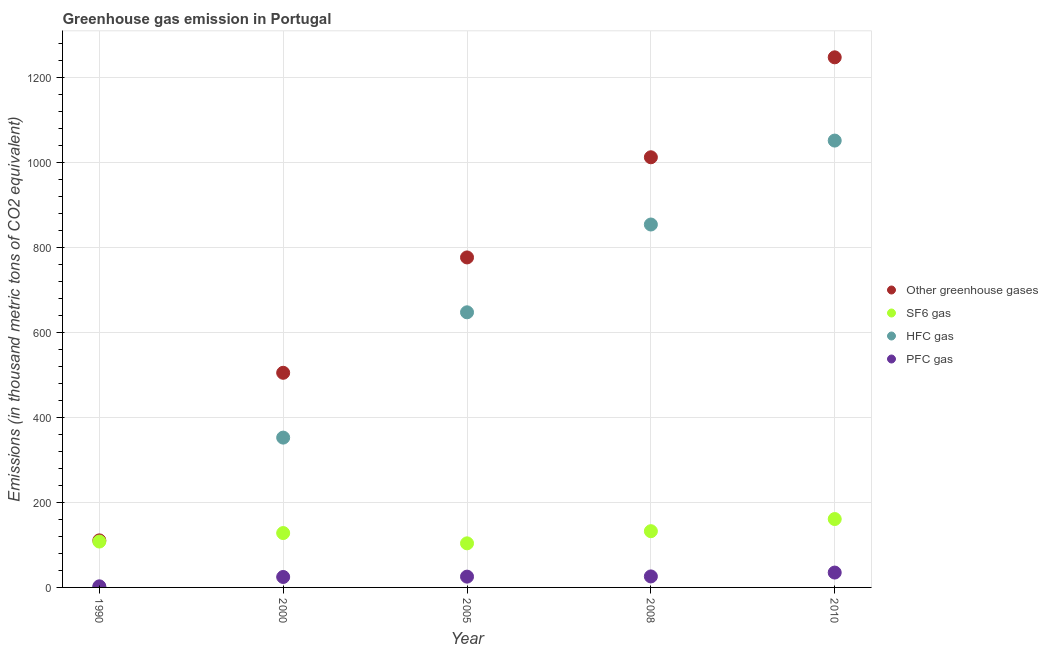How many different coloured dotlines are there?
Offer a very short reply. 4. Is the number of dotlines equal to the number of legend labels?
Give a very brief answer. Yes. What is the emission of hfc gas in 2008?
Offer a terse response. 854.4. Across all years, what is the maximum emission of greenhouse gases?
Your answer should be very brief. 1248. Across all years, what is the minimum emission of hfc gas?
Ensure brevity in your answer.  0.2. In which year was the emission of greenhouse gases maximum?
Your answer should be compact. 2010. What is the total emission of sf6 gas in the graph?
Ensure brevity in your answer.  633.2. What is the difference between the emission of greenhouse gases in 2005 and that in 2008?
Your response must be concise. -235.8. What is the difference between the emission of sf6 gas in 1990 and the emission of greenhouse gases in 2005?
Offer a very short reply. -668.9. What is the average emission of greenhouse gases per year?
Make the answer very short. 730.74. In the year 2000, what is the difference between the emission of greenhouse gases and emission of pfc gas?
Offer a very short reply. 480.7. What is the ratio of the emission of greenhouse gases in 2000 to that in 2010?
Ensure brevity in your answer.  0.4. Is the emission of hfc gas in 1990 less than that in 2008?
Offer a terse response. Yes. Is the difference between the emission of hfc gas in 2005 and 2008 greater than the difference between the emission of greenhouse gases in 2005 and 2008?
Offer a very short reply. Yes. What is the difference between the highest and the second highest emission of pfc gas?
Offer a very short reply. 9.1. What is the difference between the highest and the lowest emission of hfc gas?
Provide a succinct answer. 1051.8. In how many years, is the emission of pfc gas greater than the average emission of pfc gas taken over all years?
Ensure brevity in your answer.  4. Is the sum of the emission of sf6 gas in 1990 and 2000 greater than the maximum emission of greenhouse gases across all years?
Make the answer very short. No. Does the emission of sf6 gas monotonically increase over the years?
Offer a very short reply. No. Is the emission of pfc gas strictly less than the emission of hfc gas over the years?
Keep it short and to the point. No. How many dotlines are there?
Offer a very short reply. 4. How many years are there in the graph?
Give a very brief answer. 5. Are the values on the major ticks of Y-axis written in scientific E-notation?
Offer a very short reply. No. Does the graph contain any zero values?
Your answer should be very brief. No. Where does the legend appear in the graph?
Your answer should be compact. Center right. How many legend labels are there?
Your response must be concise. 4. What is the title of the graph?
Your answer should be compact. Greenhouse gas emission in Portugal. Does "Energy" appear as one of the legend labels in the graph?
Make the answer very short. No. What is the label or title of the X-axis?
Offer a very short reply. Year. What is the label or title of the Y-axis?
Offer a very short reply. Emissions (in thousand metric tons of CO2 equivalent). What is the Emissions (in thousand metric tons of CO2 equivalent) in Other greenhouse gases in 1990?
Your answer should be very brief. 110.8. What is the Emissions (in thousand metric tons of CO2 equivalent) in SF6 gas in 1990?
Keep it short and to the point. 108. What is the Emissions (in thousand metric tons of CO2 equivalent) of HFC gas in 1990?
Offer a terse response. 0.2. What is the Emissions (in thousand metric tons of CO2 equivalent) of Other greenhouse gases in 2000?
Provide a succinct answer. 505.3. What is the Emissions (in thousand metric tons of CO2 equivalent) in SF6 gas in 2000?
Make the answer very short. 128. What is the Emissions (in thousand metric tons of CO2 equivalent) in HFC gas in 2000?
Your response must be concise. 352.7. What is the Emissions (in thousand metric tons of CO2 equivalent) in PFC gas in 2000?
Ensure brevity in your answer.  24.6. What is the Emissions (in thousand metric tons of CO2 equivalent) in Other greenhouse gases in 2005?
Make the answer very short. 776.9. What is the Emissions (in thousand metric tons of CO2 equivalent) in SF6 gas in 2005?
Offer a very short reply. 103.8. What is the Emissions (in thousand metric tons of CO2 equivalent) in HFC gas in 2005?
Your response must be concise. 647.7. What is the Emissions (in thousand metric tons of CO2 equivalent) of PFC gas in 2005?
Your response must be concise. 25.4. What is the Emissions (in thousand metric tons of CO2 equivalent) of Other greenhouse gases in 2008?
Provide a short and direct response. 1012.7. What is the Emissions (in thousand metric tons of CO2 equivalent) in SF6 gas in 2008?
Offer a very short reply. 132.4. What is the Emissions (in thousand metric tons of CO2 equivalent) of HFC gas in 2008?
Make the answer very short. 854.4. What is the Emissions (in thousand metric tons of CO2 equivalent) in PFC gas in 2008?
Your answer should be very brief. 25.9. What is the Emissions (in thousand metric tons of CO2 equivalent) of Other greenhouse gases in 2010?
Your response must be concise. 1248. What is the Emissions (in thousand metric tons of CO2 equivalent) in SF6 gas in 2010?
Your answer should be compact. 161. What is the Emissions (in thousand metric tons of CO2 equivalent) in HFC gas in 2010?
Make the answer very short. 1052. What is the Emissions (in thousand metric tons of CO2 equivalent) of PFC gas in 2010?
Offer a very short reply. 35. Across all years, what is the maximum Emissions (in thousand metric tons of CO2 equivalent) in Other greenhouse gases?
Offer a terse response. 1248. Across all years, what is the maximum Emissions (in thousand metric tons of CO2 equivalent) in SF6 gas?
Make the answer very short. 161. Across all years, what is the maximum Emissions (in thousand metric tons of CO2 equivalent) in HFC gas?
Your answer should be compact. 1052. Across all years, what is the minimum Emissions (in thousand metric tons of CO2 equivalent) of Other greenhouse gases?
Make the answer very short. 110.8. Across all years, what is the minimum Emissions (in thousand metric tons of CO2 equivalent) in SF6 gas?
Your answer should be very brief. 103.8. Across all years, what is the minimum Emissions (in thousand metric tons of CO2 equivalent) of PFC gas?
Your response must be concise. 2.6. What is the total Emissions (in thousand metric tons of CO2 equivalent) in Other greenhouse gases in the graph?
Keep it short and to the point. 3653.7. What is the total Emissions (in thousand metric tons of CO2 equivalent) of SF6 gas in the graph?
Your response must be concise. 633.2. What is the total Emissions (in thousand metric tons of CO2 equivalent) of HFC gas in the graph?
Your response must be concise. 2907. What is the total Emissions (in thousand metric tons of CO2 equivalent) of PFC gas in the graph?
Keep it short and to the point. 113.5. What is the difference between the Emissions (in thousand metric tons of CO2 equivalent) in Other greenhouse gases in 1990 and that in 2000?
Your answer should be compact. -394.5. What is the difference between the Emissions (in thousand metric tons of CO2 equivalent) in HFC gas in 1990 and that in 2000?
Give a very brief answer. -352.5. What is the difference between the Emissions (in thousand metric tons of CO2 equivalent) in Other greenhouse gases in 1990 and that in 2005?
Give a very brief answer. -666.1. What is the difference between the Emissions (in thousand metric tons of CO2 equivalent) in HFC gas in 1990 and that in 2005?
Your response must be concise. -647.5. What is the difference between the Emissions (in thousand metric tons of CO2 equivalent) in PFC gas in 1990 and that in 2005?
Make the answer very short. -22.8. What is the difference between the Emissions (in thousand metric tons of CO2 equivalent) of Other greenhouse gases in 1990 and that in 2008?
Provide a succinct answer. -901.9. What is the difference between the Emissions (in thousand metric tons of CO2 equivalent) in SF6 gas in 1990 and that in 2008?
Offer a terse response. -24.4. What is the difference between the Emissions (in thousand metric tons of CO2 equivalent) of HFC gas in 1990 and that in 2008?
Ensure brevity in your answer.  -854.2. What is the difference between the Emissions (in thousand metric tons of CO2 equivalent) of PFC gas in 1990 and that in 2008?
Make the answer very short. -23.3. What is the difference between the Emissions (in thousand metric tons of CO2 equivalent) in Other greenhouse gases in 1990 and that in 2010?
Provide a succinct answer. -1137.2. What is the difference between the Emissions (in thousand metric tons of CO2 equivalent) in SF6 gas in 1990 and that in 2010?
Give a very brief answer. -53. What is the difference between the Emissions (in thousand metric tons of CO2 equivalent) of HFC gas in 1990 and that in 2010?
Give a very brief answer. -1051.8. What is the difference between the Emissions (in thousand metric tons of CO2 equivalent) in PFC gas in 1990 and that in 2010?
Offer a very short reply. -32.4. What is the difference between the Emissions (in thousand metric tons of CO2 equivalent) of Other greenhouse gases in 2000 and that in 2005?
Offer a terse response. -271.6. What is the difference between the Emissions (in thousand metric tons of CO2 equivalent) in SF6 gas in 2000 and that in 2005?
Provide a succinct answer. 24.2. What is the difference between the Emissions (in thousand metric tons of CO2 equivalent) of HFC gas in 2000 and that in 2005?
Offer a terse response. -295. What is the difference between the Emissions (in thousand metric tons of CO2 equivalent) in Other greenhouse gases in 2000 and that in 2008?
Make the answer very short. -507.4. What is the difference between the Emissions (in thousand metric tons of CO2 equivalent) in HFC gas in 2000 and that in 2008?
Make the answer very short. -501.7. What is the difference between the Emissions (in thousand metric tons of CO2 equivalent) of PFC gas in 2000 and that in 2008?
Give a very brief answer. -1.3. What is the difference between the Emissions (in thousand metric tons of CO2 equivalent) of Other greenhouse gases in 2000 and that in 2010?
Provide a succinct answer. -742.7. What is the difference between the Emissions (in thousand metric tons of CO2 equivalent) of SF6 gas in 2000 and that in 2010?
Your answer should be compact. -33. What is the difference between the Emissions (in thousand metric tons of CO2 equivalent) in HFC gas in 2000 and that in 2010?
Keep it short and to the point. -699.3. What is the difference between the Emissions (in thousand metric tons of CO2 equivalent) of PFC gas in 2000 and that in 2010?
Make the answer very short. -10.4. What is the difference between the Emissions (in thousand metric tons of CO2 equivalent) in Other greenhouse gases in 2005 and that in 2008?
Make the answer very short. -235.8. What is the difference between the Emissions (in thousand metric tons of CO2 equivalent) in SF6 gas in 2005 and that in 2008?
Your response must be concise. -28.6. What is the difference between the Emissions (in thousand metric tons of CO2 equivalent) in HFC gas in 2005 and that in 2008?
Offer a very short reply. -206.7. What is the difference between the Emissions (in thousand metric tons of CO2 equivalent) in Other greenhouse gases in 2005 and that in 2010?
Offer a very short reply. -471.1. What is the difference between the Emissions (in thousand metric tons of CO2 equivalent) of SF6 gas in 2005 and that in 2010?
Provide a succinct answer. -57.2. What is the difference between the Emissions (in thousand metric tons of CO2 equivalent) in HFC gas in 2005 and that in 2010?
Offer a terse response. -404.3. What is the difference between the Emissions (in thousand metric tons of CO2 equivalent) of PFC gas in 2005 and that in 2010?
Make the answer very short. -9.6. What is the difference between the Emissions (in thousand metric tons of CO2 equivalent) in Other greenhouse gases in 2008 and that in 2010?
Offer a very short reply. -235.3. What is the difference between the Emissions (in thousand metric tons of CO2 equivalent) in SF6 gas in 2008 and that in 2010?
Give a very brief answer. -28.6. What is the difference between the Emissions (in thousand metric tons of CO2 equivalent) in HFC gas in 2008 and that in 2010?
Ensure brevity in your answer.  -197.6. What is the difference between the Emissions (in thousand metric tons of CO2 equivalent) in PFC gas in 2008 and that in 2010?
Provide a succinct answer. -9.1. What is the difference between the Emissions (in thousand metric tons of CO2 equivalent) of Other greenhouse gases in 1990 and the Emissions (in thousand metric tons of CO2 equivalent) of SF6 gas in 2000?
Make the answer very short. -17.2. What is the difference between the Emissions (in thousand metric tons of CO2 equivalent) of Other greenhouse gases in 1990 and the Emissions (in thousand metric tons of CO2 equivalent) of HFC gas in 2000?
Make the answer very short. -241.9. What is the difference between the Emissions (in thousand metric tons of CO2 equivalent) in Other greenhouse gases in 1990 and the Emissions (in thousand metric tons of CO2 equivalent) in PFC gas in 2000?
Make the answer very short. 86.2. What is the difference between the Emissions (in thousand metric tons of CO2 equivalent) of SF6 gas in 1990 and the Emissions (in thousand metric tons of CO2 equivalent) of HFC gas in 2000?
Make the answer very short. -244.7. What is the difference between the Emissions (in thousand metric tons of CO2 equivalent) of SF6 gas in 1990 and the Emissions (in thousand metric tons of CO2 equivalent) of PFC gas in 2000?
Ensure brevity in your answer.  83.4. What is the difference between the Emissions (in thousand metric tons of CO2 equivalent) of HFC gas in 1990 and the Emissions (in thousand metric tons of CO2 equivalent) of PFC gas in 2000?
Offer a terse response. -24.4. What is the difference between the Emissions (in thousand metric tons of CO2 equivalent) of Other greenhouse gases in 1990 and the Emissions (in thousand metric tons of CO2 equivalent) of SF6 gas in 2005?
Your answer should be compact. 7. What is the difference between the Emissions (in thousand metric tons of CO2 equivalent) of Other greenhouse gases in 1990 and the Emissions (in thousand metric tons of CO2 equivalent) of HFC gas in 2005?
Your answer should be very brief. -536.9. What is the difference between the Emissions (in thousand metric tons of CO2 equivalent) of Other greenhouse gases in 1990 and the Emissions (in thousand metric tons of CO2 equivalent) of PFC gas in 2005?
Your response must be concise. 85.4. What is the difference between the Emissions (in thousand metric tons of CO2 equivalent) in SF6 gas in 1990 and the Emissions (in thousand metric tons of CO2 equivalent) in HFC gas in 2005?
Your response must be concise. -539.7. What is the difference between the Emissions (in thousand metric tons of CO2 equivalent) in SF6 gas in 1990 and the Emissions (in thousand metric tons of CO2 equivalent) in PFC gas in 2005?
Give a very brief answer. 82.6. What is the difference between the Emissions (in thousand metric tons of CO2 equivalent) of HFC gas in 1990 and the Emissions (in thousand metric tons of CO2 equivalent) of PFC gas in 2005?
Offer a terse response. -25.2. What is the difference between the Emissions (in thousand metric tons of CO2 equivalent) in Other greenhouse gases in 1990 and the Emissions (in thousand metric tons of CO2 equivalent) in SF6 gas in 2008?
Keep it short and to the point. -21.6. What is the difference between the Emissions (in thousand metric tons of CO2 equivalent) of Other greenhouse gases in 1990 and the Emissions (in thousand metric tons of CO2 equivalent) of HFC gas in 2008?
Your answer should be compact. -743.6. What is the difference between the Emissions (in thousand metric tons of CO2 equivalent) in Other greenhouse gases in 1990 and the Emissions (in thousand metric tons of CO2 equivalent) in PFC gas in 2008?
Make the answer very short. 84.9. What is the difference between the Emissions (in thousand metric tons of CO2 equivalent) of SF6 gas in 1990 and the Emissions (in thousand metric tons of CO2 equivalent) of HFC gas in 2008?
Your answer should be very brief. -746.4. What is the difference between the Emissions (in thousand metric tons of CO2 equivalent) in SF6 gas in 1990 and the Emissions (in thousand metric tons of CO2 equivalent) in PFC gas in 2008?
Your answer should be compact. 82.1. What is the difference between the Emissions (in thousand metric tons of CO2 equivalent) in HFC gas in 1990 and the Emissions (in thousand metric tons of CO2 equivalent) in PFC gas in 2008?
Offer a terse response. -25.7. What is the difference between the Emissions (in thousand metric tons of CO2 equivalent) of Other greenhouse gases in 1990 and the Emissions (in thousand metric tons of CO2 equivalent) of SF6 gas in 2010?
Ensure brevity in your answer.  -50.2. What is the difference between the Emissions (in thousand metric tons of CO2 equivalent) of Other greenhouse gases in 1990 and the Emissions (in thousand metric tons of CO2 equivalent) of HFC gas in 2010?
Keep it short and to the point. -941.2. What is the difference between the Emissions (in thousand metric tons of CO2 equivalent) of Other greenhouse gases in 1990 and the Emissions (in thousand metric tons of CO2 equivalent) of PFC gas in 2010?
Ensure brevity in your answer.  75.8. What is the difference between the Emissions (in thousand metric tons of CO2 equivalent) of SF6 gas in 1990 and the Emissions (in thousand metric tons of CO2 equivalent) of HFC gas in 2010?
Offer a terse response. -944. What is the difference between the Emissions (in thousand metric tons of CO2 equivalent) in HFC gas in 1990 and the Emissions (in thousand metric tons of CO2 equivalent) in PFC gas in 2010?
Your answer should be very brief. -34.8. What is the difference between the Emissions (in thousand metric tons of CO2 equivalent) of Other greenhouse gases in 2000 and the Emissions (in thousand metric tons of CO2 equivalent) of SF6 gas in 2005?
Offer a very short reply. 401.5. What is the difference between the Emissions (in thousand metric tons of CO2 equivalent) of Other greenhouse gases in 2000 and the Emissions (in thousand metric tons of CO2 equivalent) of HFC gas in 2005?
Offer a terse response. -142.4. What is the difference between the Emissions (in thousand metric tons of CO2 equivalent) of Other greenhouse gases in 2000 and the Emissions (in thousand metric tons of CO2 equivalent) of PFC gas in 2005?
Provide a succinct answer. 479.9. What is the difference between the Emissions (in thousand metric tons of CO2 equivalent) of SF6 gas in 2000 and the Emissions (in thousand metric tons of CO2 equivalent) of HFC gas in 2005?
Offer a very short reply. -519.7. What is the difference between the Emissions (in thousand metric tons of CO2 equivalent) in SF6 gas in 2000 and the Emissions (in thousand metric tons of CO2 equivalent) in PFC gas in 2005?
Your answer should be very brief. 102.6. What is the difference between the Emissions (in thousand metric tons of CO2 equivalent) of HFC gas in 2000 and the Emissions (in thousand metric tons of CO2 equivalent) of PFC gas in 2005?
Your answer should be compact. 327.3. What is the difference between the Emissions (in thousand metric tons of CO2 equivalent) of Other greenhouse gases in 2000 and the Emissions (in thousand metric tons of CO2 equivalent) of SF6 gas in 2008?
Offer a terse response. 372.9. What is the difference between the Emissions (in thousand metric tons of CO2 equivalent) of Other greenhouse gases in 2000 and the Emissions (in thousand metric tons of CO2 equivalent) of HFC gas in 2008?
Your response must be concise. -349.1. What is the difference between the Emissions (in thousand metric tons of CO2 equivalent) in Other greenhouse gases in 2000 and the Emissions (in thousand metric tons of CO2 equivalent) in PFC gas in 2008?
Your answer should be compact. 479.4. What is the difference between the Emissions (in thousand metric tons of CO2 equivalent) in SF6 gas in 2000 and the Emissions (in thousand metric tons of CO2 equivalent) in HFC gas in 2008?
Ensure brevity in your answer.  -726.4. What is the difference between the Emissions (in thousand metric tons of CO2 equivalent) of SF6 gas in 2000 and the Emissions (in thousand metric tons of CO2 equivalent) of PFC gas in 2008?
Provide a short and direct response. 102.1. What is the difference between the Emissions (in thousand metric tons of CO2 equivalent) in HFC gas in 2000 and the Emissions (in thousand metric tons of CO2 equivalent) in PFC gas in 2008?
Offer a very short reply. 326.8. What is the difference between the Emissions (in thousand metric tons of CO2 equivalent) of Other greenhouse gases in 2000 and the Emissions (in thousand metric tons of CO2 equivalent) of SF6 gas in 2010?
Provide a succinct answer. 344.3. What is the difference between the Emissions (in thousand metric tons of CO2 equivalent) in Other greenhouse gases in 2000 and the Emissions (in thousand metric tons of CO2 equivalent) in HFC gas in 2010?
Your answer should be compact. -546.7. What is the difference between the Emissions (in thousand metric tons of CO2 equivalent) of Other greenhouse gases in 2000 and the Emissions (in thousand metric tons of CO2 equivalent) of PFC gas in 2010?
Make the answer very short. 470.3. What is the difference between the Emissions (in thousand metric tons of CO2 equivalent) in SF6 gas in 2000 and the Emissions (in thousand metric tons of CO2 equivalent) in HFC gas in 2010?
Your response must be concise. -924. What is the difference between the Emissions (in thousand metric tons of CO2 equivalent) in SF6 gas in 2000 and the Emissions (in thousand metric tons of CO2 equivalent) in PFC gas in 2010?
Make the answer very short. 93. What is the difference between the Emissions (in thousand metric tons of CO2 equivalent) in HFC gas in 2000 and the Emissions (in thousand metric tons of CO2 equivalent) in PFC gas in 2010?
Offer a terse response. 317.7. What is the difference between the Emissions (in thousand metric tons of CO2 equivalent) of Other greenhouse gases in 2005 and the Emissions (in thousand metric tons of CO2 equivalent) of SF6 gas in 2008?
Keep it short and to the point. 644.5. What is the difference between the Emissions (in thousand metric tons of CO2 equivalent) in Other greenhouse gases in 2005 and the Emissions (in thousand metric tons of CO2 equivalent) in HFC gas in 2008?
Your answer should be very brief. -77.5. What is the difference between the Emissions (in thousand metric tons of CO2 equivalent) in Other greenhouse gases in 2005 and the Emissions (in thousand metric tons of CO2 equivalent) in PFC gas in 2008?
Offer a very short reply. 751. What is the difference between the Emissions (in thousand metric tons of CO2 equivalent) of SF6 gas in 2005 and the Emissions (in thousand metric tons of CO2 equivalent) of HFC gas in 2008?
Provide a succinct answer. -750.6. What is the difference between the Emissions (in thousand metric tons of CO2 equivalent) of SF6 gas in 2005 and the Emissions (in thousand metric tons of CO2 equivalent) of PFC gas in 2008?
Offer a terse response. 77.9. What is the difference between the Emissions (in thousand metric tons of CO2 equivalent) in HFC gas in 2005 and the Emissions (in thousand metric tons of CO2 equivalent) in PFC gas in 2008?
Offer a terse response. 621.8. What is the difference between the Emissions (in thousand metric tons of CO2 equivalent) in Other greenhouse gases in 2005 and the Emissions (in thousand metric tons of CO2 equivalent) in SF6 gas in 2010?
Give a very brief answer. 615.9. What is the difference between the Emissions (in thousand metric tons of CO2 equivalent) of Other greenhouse gases in 2005 and the Emissions (in thousand metric tons of CO2 equivalent) of HFC gas in 2010?
Make the answer very short. -275.1. What is the difference between the Emissions (in thousand metric tons of CO2 equivalent) in Other greenhouse gases in 2005 and the Emissions (in thousand metric tons of CO2 equivalent) in PFC gas in 2010?
Offer a terse response. 741.9. What is the difference between the Emissions (in thousand metric tons of CO2 equivalent) of SF6 gas in 2005 and the Emissions (in thousand metric tons of CO2 equivalent) of HFC gas in 2010?
Your answer should be very brief. -948.2. What is the difference between the Emissions (in thousand metric tons of CO2 equivalent) in SF6 gas in 2005 and the Emissions (in thousand metric tons of CO2 equivalent) in PFC gas in 2010?
Ensure brevity in your answer.  68.8. What is the difference between the Emissions (in thousand metric tons of CO2 equivalent) of HFC gas in 2005 and the Emissions (in thousand metric tons of CO2 equivalent) of PFC gas in 2010?
Keep it short and to the point. 612.7. What is the difference between the Emissions (in thousand metric tons of CO2 equivalent) in Other greenhouse gases in 2008 and the Emissions (in thousand metric tons of CO2 equivalent) in SF6 gas in 2010?
Ensure brevity in your answer.  851.7. What is the difference between the Emissions (in thousand metric tons of CO2 equivalent) of Other greenhouse gases in 2008 and the Emissions (in thousand metric tons of CO2 equivalent) of HFC gas in 2010?
Provide a succinct answer. -39.3. What is the difference between the Emissions (in thousand metric tons of CO2 equivalent) of Other greenhouse gases in 2008 and the Emissions (in thousand metric tons of CO2 equivalent) of PFC gas in 2010?
Your response must be concise. 977.7. What is the difference between the Emissions (in thousand metric tons of CO2 equivalent) in SF6 gas in 2008 and the Emissions (in thousand metric tons of CO2 equivalent) in HFC gas in 2010?
Give a very brief answer. -919.6. What is the difference between the Emissions (in thousand metric tons of CO2 equivalent) in SF6 gas in 2008 and the Emissions (in thousand metric tons of CO2 equivalent) in PFC gas in 2010?
Offer a terse response. 97.4. What is the difference between the Emissions (in thousand metric tons of CO2 equivalent) in HFC gas in 2008 and the Emissions (in thousand metric tons of CO2 equivalent) in PFC gas in 2010?
Your answer should be compact. 819.4. What is the average Emissions (in thousand metric tons of CO2 equivalent) of Other greenhouse gases per year?
Make the answer very short. 730.74. What is the average Emissions (in thousand metric tons of CO2 equivalent) in SF6 gas per year?
Make the answer very short. 126.64. What is the average Emissions (in thousand metric tons of CO2 equivalent) of HFC gas per year?
Provide a succinct answer. 581.4. What is the average Emissions (in thousand metric tons of CO2 equivalent) of PFC gas per year?
Your answer should be very brief. 22.7. In the year 1990, what is the difference between the Emissions (in thousand metric tons of CO2 equivalent) in Other greenhouse gases and Emissions (in thousand metric tons of CO2 equivalent) in SF6 gas?
Keep it short and to the point. 2.8. In the year 1990, what is the difference between the Emissions (in thousand metric tons of CO2 equivalent) in Other greenhouse gases and Emissions (in thousand metric tons of CO2 equivalent) in HFC gas?
Make the answer very short. 110.6. In the year 1990, what is the difference between the Emissions (in thousand metric tons of CO2 equivalent) in Other greenhouse gases and Emissions (in thousand metric tons of CO2 equivalent) in PFC gas?
Keep it short and to the point. 108.2. In the year 1990, what is the difference between the Emissions (in thousand metric tons of CO2 equivalent) in SF6 gas and Emissions (in thousand metric tons of CO2 equivalent) in HFC gas?
Offer a terse response. 107.8. In the year 1990, what is the difference between the Emissions (in thousand metric tons of CO2 equivalent) of SF6 gas and Emissions (in thousand metric tons of CO2 equivalent) of PFC gas?
Keep it short and to the point. 105.4. In the year 1990, what is the difference between the Emissions (in thousand metric tons of CO2 equivalent) of HFC gas and Emissions (in thousand metric tons of CO2 equivalent) of PFC gas?
Ensure brevity in your answer.  -2.4. In the year 2000, what is the difference between the Emissions (in thousand metric tons of CO2 equivalent) in Other greenhouse gases and Emissions (in thousand metric tons of CO2 equivalent) in SF6 gas?
Provide a short and direct response. 377.3. In the year 2000, what is the difference between the Emissions (in thousand metric tons of CO2 equivalent) in Other greenhouse gases and Emissions (in thousand metric tons of CO2 equivalent) in HFC gas?
Your answer should be very brief. 152.6. In the year 2000, what is the difference between the Emissions (in thousand metric tons of CO2 equivalent) in Other greenhouse gases and Emissions (in thousand metric tons of CO2 equivalent) in PFC gas?
Your answer should be very brief. 480.7. In the year 2000, what is the difference between the Emissions (in thousand metric tons of CO2 equivalent) of SF6 gas and Emissions (in thousand metric tons of CO2 equivalent) of HFC gas?
Offer a very short reply. -224.7. In the year 2000, what is the difference between the Emissions (in thousand metric tons of CO2 equivalent) in SF6 gas and Emissions (in thousand metric tons of CO2 equivalent) in PFC gas?
Your response must be concise. 103.4. In the year 2000, what is the difference between the Emissions (in thousand metric tons of CO2 equivalent) of HFC gas and Emissions (in thousand metric tons of CO2 equivalent) of PFC gas?
Provide a short and direct response. 328.1. In the year 2005, what is the difference between the Emissions (in thousand metric tons of CO2 equivalent) in Other greenhouse gases and Emissions (in thousand metric tons of CO2 equivalent) in SF6 gas?
Provide a succinct answer. 673.1. In the year 2005, what is the difference between the Emissions (in thousand metric tons of CO2 equivalent) of Other greenhouse gases and Emissions (in thousand metric tons of CO2 equivalent) of HFC gas?
Offer a very short reply. 129.2. In the year 2005, what is the difference between the Emissions (in thousand metric tons of CO2 equivalent) of Other greenhouse gases and Emissions (in thousand metric tons of CO2 equivalent) of PFC gas?
Your response must be concise. 751.5. In the year 2005, what is the difference between the Emissions (in thousand metric tons of CO2 equivalent) in SF6 gas and Emissions (in thousand metric tons of CO2 equivalent) in HFC gas?
Give a very brief answer. -543.9. In the year 2005, what is the difference between the Emissions (in thousand metric tons of CO2 equivalent) of SF6 gas and Emissions (in thousand metric tons of CO2 equivalent) of PFC gas?
Keep it short and to the point. 78.4. In the year 2005, what is the difference between the Emissions (in thousand metric tons of CO2 equivalent) of HFC gas and Emissions (in thousand metric tons of CO2 equivalent) of PFC gas?
Make the answer very short. 622.3. In the year 2008, what is the difference between the Emissions (in thousand metric tons of CO2 equivalent) of Other greenhouse gases and Emissions (in thousand metric tons of CO2 equivalent) of SF6 gas?
Give a very brief answer. 880.3. In the year 2008, what is the difference between the Emissions (in thousand metric tons of CO2 equivalent) in Other greenhouse gases and Emissions (in thousand metric tons of CO2 equivalent) in HFC gas?
Offer a very short reply. 158.3. In the year 2008, what is the difference between the Emissions (in thousand metric tons of CO2 equivalent) of Other greenhouse gases and Emissions (in thousand metric tons of CO2 equivalent) of PFC gas?
Offer a very short reply. 986.8. In the year 2008, what is the difference between the Emissions (in thousand metric tons of CO2 equivalent) of SF6 gas and Emissions (in thousand metric tons of CO2 equivalent) of HFC gas?
Give a very brief answer. -722. In the year 2008, what is the difference between the Emissions (in thousand metric tons of CO2 equivalent) in SF6 gas and Emissions (in thousand metric tons of CO2 equivalent) in PFC gas?
Provide a succinct answer. 106.5. In the year 2008, what is the difference between the Emissions (in thousand metric tons of CO2 equivalent) of HFC gas and Emissions (in thousand metric tons of CO2 equivalent) of PFC gas?
Offer a terse response. 828.5. In the year 2010, what is the difference between the Emissions (in thousand metric tons of CO2 equivalent) in Other greenhouse gases and Emissions (in thousand metric tons of CO2 equivalent) in SF6 gas?
Your answer should be very brief. 1087. In the year 2010, what is the difference between the Emissions (in thousand metric tons of CO2 equivalent) in Other greenhouse gases and Emissions (in thousand metric tons of CO2 equivalent) in HFC gas?
Your response must be concise. 196. In the year 2010, what is the difference between the Emissions (in thousand metric tons of CO2 equivalent) in Other greenhouse gases and Emissions (in thousand metric tons of CO2 equivalent) in PFC gas?
Keep it short and to the point. 1213. In the year 2010, what is the difference between the Emissions (in thousand metric tons of CO2 equivalent) in SF6 gas and Emissions (in thousand metric tons of CO2 equivalent) in HFC gas?
Give a very brief answer. -891. In the year 2010, what is the difference between the Emissions (in thousand metric tons of CO2 equivalent) of SF6 gas and Emissions (in thousand metric tons of CO2 equivalent) of PFC gas?
Your answer should be compact. 126. In the year 2010, what is the difference between the Emissions (in thousand metric tons of CO2 equivalent) in HFC gas and Emissions (in thousand metric tons of CO2 equivalent) in PFC gas?
Your answer should be compact. 1017. What is the ratio of the Emissions (in thousand metric tons of CO2 equivalent) in Other greenhouse gases in 1990 to that in 2000?
Make the answer very short. 0.22. What is the ratio of the Emissions (in thousand metric tons of CO2 equivalent) of SF6 gas in 1990 to that in 2000?
Ensure brevity in your answer.  0.84. What is the ratio of the Emissions (in thousand metric tons of CO2 equivalent) in HFC gas in 1990 to that in 2000?
Your response must be concise. 0. What is the ratio of the Emissions (in thousand metric tons of CO2 equivalent) in PFC gas in 1990 to that in 2000?
Offer a terse response. 0.11. What is the ratio of the Emissions (in thousand metric tons of CO2 equivalent) of Other greenhouse gases in 1990 to that in 2005?
Your answer should be compact. 0.14. What is the ratio of the Emissions (in thousand metric tons of CO2 equivalent) of SF6 gas in 1990 to that in 2005?
Your answer should be very brief. 1.04. What is the ratio of the Emissions (in thousand metric tons of CO2 equivalent) in PFC gas in 1990 to that in 2005?
Offer a terse response. 0.1. What is the ratio of the Emissions (in thousand metric tons of CO2 equivalent) of Other greenhouse gases in 1990 to that in 2008?
Your response must be concise. 0.11. What is the ratio of the Emissions (in thousand metric tons of CO2 equivalent) of SF6 gas in 1990 to that in 2008?
Provide a succinct answer. 0.82. What is the ratio of the Emissions (in thousand metric tons of CO2 equivalent) in HFC gas in 1990 to that in 2008?
Your answer should be very brief. 0. What is the ratio of the Emissions (in thousand metric tons of CO2 equivalent) in PFC gas in 1990 to that in 2008?
Your response must be concise. 0.1. What is the ratio of the Emissions (in thousand metric tons of CO2 equivalent) of Other greenhouse gases in 1990 to that in 2010?
Keep it short and to the point. 0.09. What is the ratio of the Emissions (in thousand metric tons of CO2 equivalent) of SF6 gas in 1990 to that in 2010?
Provide a short and direct response. 0.67. What is the ratio of the Emissions (in thousand metric tons of CO2 equivalent) of HFC gas in 1990 to that in 2010?
Offer a terse response. 0. What is the ratio of the Emissions (in thousand metric tons of CO2 equivalent) in PFC gas in 1990 to that in 2010?
Keep it short and to the point. 0.07. What is the ratio of the Emissions (in thousand metric tons of CO2 equivalent) in Other greenhouse gases in 2000 to that in 2005?
Your response must be concise. 0.65. What is the ratio of the Emissions (in thousand metric tons of CO2 equivalent) of SF6 gas in 2000 to that in 2005?
Your response must be concise. 1.23. What is the ratio of the Emissions (in thousand metric tons of CO2 equivalent) of HFC gas in 2000 to that in 2005?
Your answer should be compact. 0.54. What is the ratio of the Emissions (in thousand metric tons of CO2 equivalent) of PFC gas in 2000 to that in 2005?
Your answer should be compact. 0.97. What is the ratio of the Emissions (in thousand metric tons of CO2 equivalent) in Other greenhouse gases in 2000 to that in 2008?
Give a very brief answer. 0.5. What is the ratio of the Emissions (in thousand metric tons of CO2 equivalent) in SF6 gas in 2000 to that in 2008?
Give a very brief answer. 0.97. What is the ratio of the Emissions (in thousand metric tons of CO2 equivalent) in HFC gas in 2000 to that in 2008?
Keep it short and to the point. 0.41. What is the ratio of the Emissions (in thousand metric tons of CO2 equivalent) of PFC gas in 2000 to that in 2008?
Offer a very short reply. 0.95. What is the ratio of the Emissions (in thousand metric tons of CO2 equivalent) of Other greenhouse gases in 2000 to that in 2010?
Offer a very short reply. 0.4. What is the ratio of the Emissions (in thousand metric tons of CO2 equivalent) of SF6 gas in 2000 to that in 2010?
Provide a succinct answer. 0.8. What is the ratio of the Emissions (in thousand metric tons of CO2 equivalent) of HFC gas in 2000 to that in 2010?
Your answer should be compact. 0.34. What is the ratio of the Emissions (in thousand metric tons of CO2 equivalent) in PFC gas in 2000 to that in 2010?
Give a very brief answer. 0.7. What is the ratio of the Emissions (in thousand metric tons of CO2 equivalent) of Other greenhouse gases in 2005 to that in 2008?
Your answer should be very brief. 0.77. What is the ratio of the Emissions (in thousand metric tons of CO2 equivalent) in SF6 gas in 2005 to that in 2008?
Ensure brevity in your answer.  0.78. What is the ratio of the Emissions (in thousand metric tons of CO2 equivalent) in HFC gas in 2005 to that in 2008?
Your answer should be compact. 0.76. What is the ratio of the Emissions (in thousand metric tons of CO2 equivalent) in PFC gas in 2005 to that in 2008?
Offer a very short reply. 0.98. What is the ratio of the Emissions (in thousand metric tons of CO2 equivalent) of Other greenhouse gases in 2005 to that in 2010?
Provide a succinct answer. 0.62. What is the ratio of the Emissions (in thousand metric tons of CO2 equivalent) of SF6 gas in 2005 to that in 2010?
Your answer should be compact. 0.64. What is the ratio of the Emissions (in thousand metric tons of CO2 equivalent) in HFC gas in 2005 to that in 2010?
Offer a very short reply. 0.62. What is the ratio of the Emissions (in thousand metric tons of CO2 equivalent) of PFC gas in 2005 to that in 2010?
Your response must be concise. 0.73. What is the ratio of the Emissions (in thousand metric tons of CO2 equivalent) of Other greenhouse gases in 2008 to that in 2010?
Ensure brevity in your answer.  0.81. What is the ratio of the Emissions (in thousand metric tons of CO2 equivalent) of SF6 gas in 2008 to that in 2010?
Offer a very short reply. 0.82. What is the ratio of the Emissions (in thousand metric tons of CO2 equivalent) of HFC gas in 2008 to that in 2010?
Ensure brevity in your answer.  0.81. What is the ratio of the Emissions (in thousand metric tons of CO2 equivalent) in PFC gas in 2008 to that in 2010?
Your answer should be very brief. 0.74. What is the difference between the highest and the second highest Emissions (in thousand metric tons of CO2 equivalent) in Other greenhouse gases?
Provide a short and direct response. 235.3. What is the difference between the highest and the second highest Emissions (in thousand metric tons of CO2 equivalent) of SF6 gas?
Keep it short and to the point. 28.6. What is the difference between the highest and the second highest Emissions (in thousand metric tons of CO2 equivalent) of HFC gas?
Your answer should be very brief. 197.6. What is the difference between the highest and the lowest Emissions (in thousand metric tons of CO2 equivalent) of Other greenhouse gases?
Make the answer very short. 1137.2. What is the difference between the highest and the lowest Emissions (in thousand metric tons of CO2 equivalent) of SF6 gas?
Provide a succinct answer. 57.2. What is the difference between the highest and the lowest Emissions (in thousand metric tons of CO2 equivalent) of HFC gas?
Offer a very short reply. 1051.8. What is the difference between the highest and the lowest Emissions (in thousand metric tons of CO2 equivalent) in PFC gas?
Offer a terse response. 32.4. 